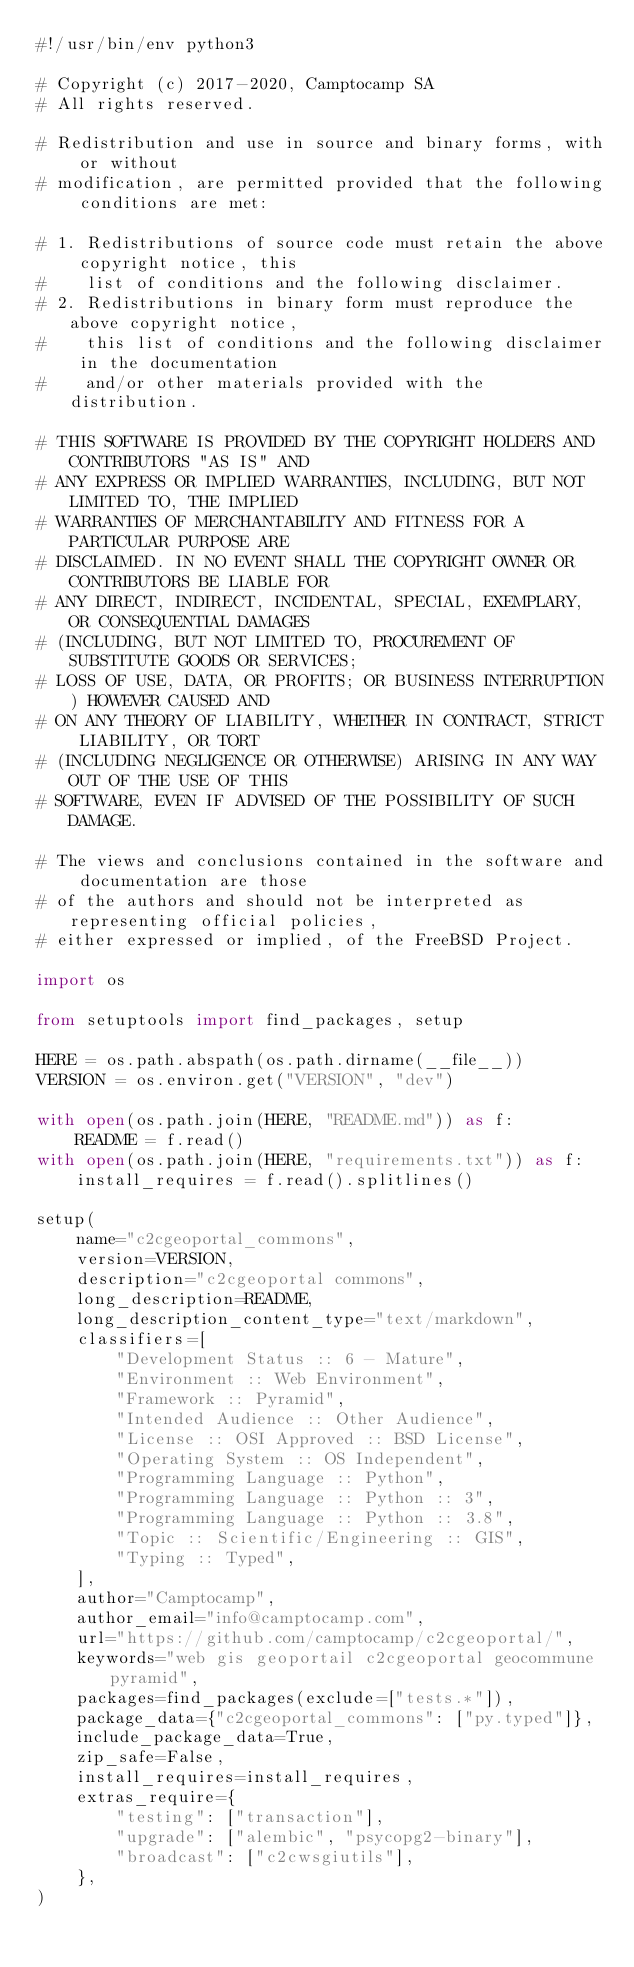Convert code to text. <code><loc_0><loc_0><loc_500><loc_500><_Python_>#!/usr/bin/env python3

# Copyright (c) 2017-2020, Camptocamp SA
# All rights reserved.

# Redistribution and use in source and binary forms, with or without
# modification, are permitted provided that the following conditions are met:

# 1. Redistributions of source code must retain the above copyright notice, this
#    list of conditions and the following disclaimer.
# 2. Redistributions in binary form must reproduce the above copyright notice,
#    this list of conditions and the following disclaimer in the documentation
#    and/or other materials provided with the distribution.

# THIS SOFTWARE IS PROVIDED BY THE COPYRIGHT HOLDERS AND CONTRIBUTORS "AS IS" AND
# ANY EXPRESS OR IMPLIED WARRANTIES, INCLUDING, BUT NOT LIMITED TO, THE IMPLIED
# WARRANTIES OF MERCHANTABILITY AND FITNESS FOR A PARTICULAR PURPOSE ARE
# DISCLAIMED. IN NO EVENT SHALL THE COPYRIGHT OWNER OR CONTRIBUTORS BE LIABLE FOR
# ANY DIRECT, INDIRECT, INCIDENTAL, SPECIAL, EXEMPLARY, OR CONSEQUENTIAL DAMAGES
# (INCLUDING, BUT NOT LIMITED TO, PROCUREMENT OF SUBSTITUTE GOODS OR SERVICES;
# LOSS OF USE, DATA, OR PROFITS; OR BUSINESS INTERRUPTION) HOWEVER CAUSED AND
# ON ANY THEORY OF LIABILITY, WHETHER IN CONTRACT, STRICT LIABILITY, OR TORT
# (INCLUDING NEGLIGENCE OR OTHERWISE) ARISING IN ANY WAY OUT OF THE USE OF THIS
# SOFTWARE, EVEN IF ADVISED OF THE POSSIBILITY OF SUCH DAMAGE.

# The views and conclusions contained in the software and documentation are those
# of the authors and should not be interpreted as representing official policies,
# either expressed or implied, of the FreeBSD Project.

import os

from setuptools import find_packages, setup

HERE = os.path.abspath(os.path.dirname(__file__))
VERSION = os.environ.get("VERSION", "dev")

with open(os.path.join(HERE, "README.md")) as f:
    README = f.read()
with open(os.path.join(HERE, "requirements.txt")) as f:
    install_requires = f.read().splitlines()

setup(
    name="c2cgeoportal_commons",
    version=VERSION,
    description="c2cgeoportal commons",
    long_description=README,
    long_description_content_type="text/markdown",
    classifiers=[
        "Development Status :: 6 - Mature",
        "Environment :: Web Environment",
        "Framework :: Pyramid",
        "Intended Audience :: Other Audience",
        "License :: OSI Approved :: BSD License",
        "Operating System :: OS Independent",
        "Programming Language :: Python",
        "Programming Language :: Python :: 3",
        "Programming Language :: Python :: 3.8",
        "Topic :: Scientific/Engineering :: GIS",
        "Typing :: Typed",
    ],
    author="Camptocamp",
    author_email="info@camptocamp.com",
    url="https://github.com/camptocamp/c2cgeoportal/",
    keywords="web gis geoportail c2cgeoportal geocommune pyramid",
    packages=find_packages(exclude=["tests.*"]),
    package_data={"c2cgeoportal_commons": ["py.typed"]},
    include_package_data=True,
    zip_safe=False,
    install_requires=install_requires,
    extras_require={
        "testing": ["transaction"],
        "upgrade": ["alembic", "psycopg2-binary"],
        "broadcast": ["c2cwsgiutils"],
    },
)
</code> 